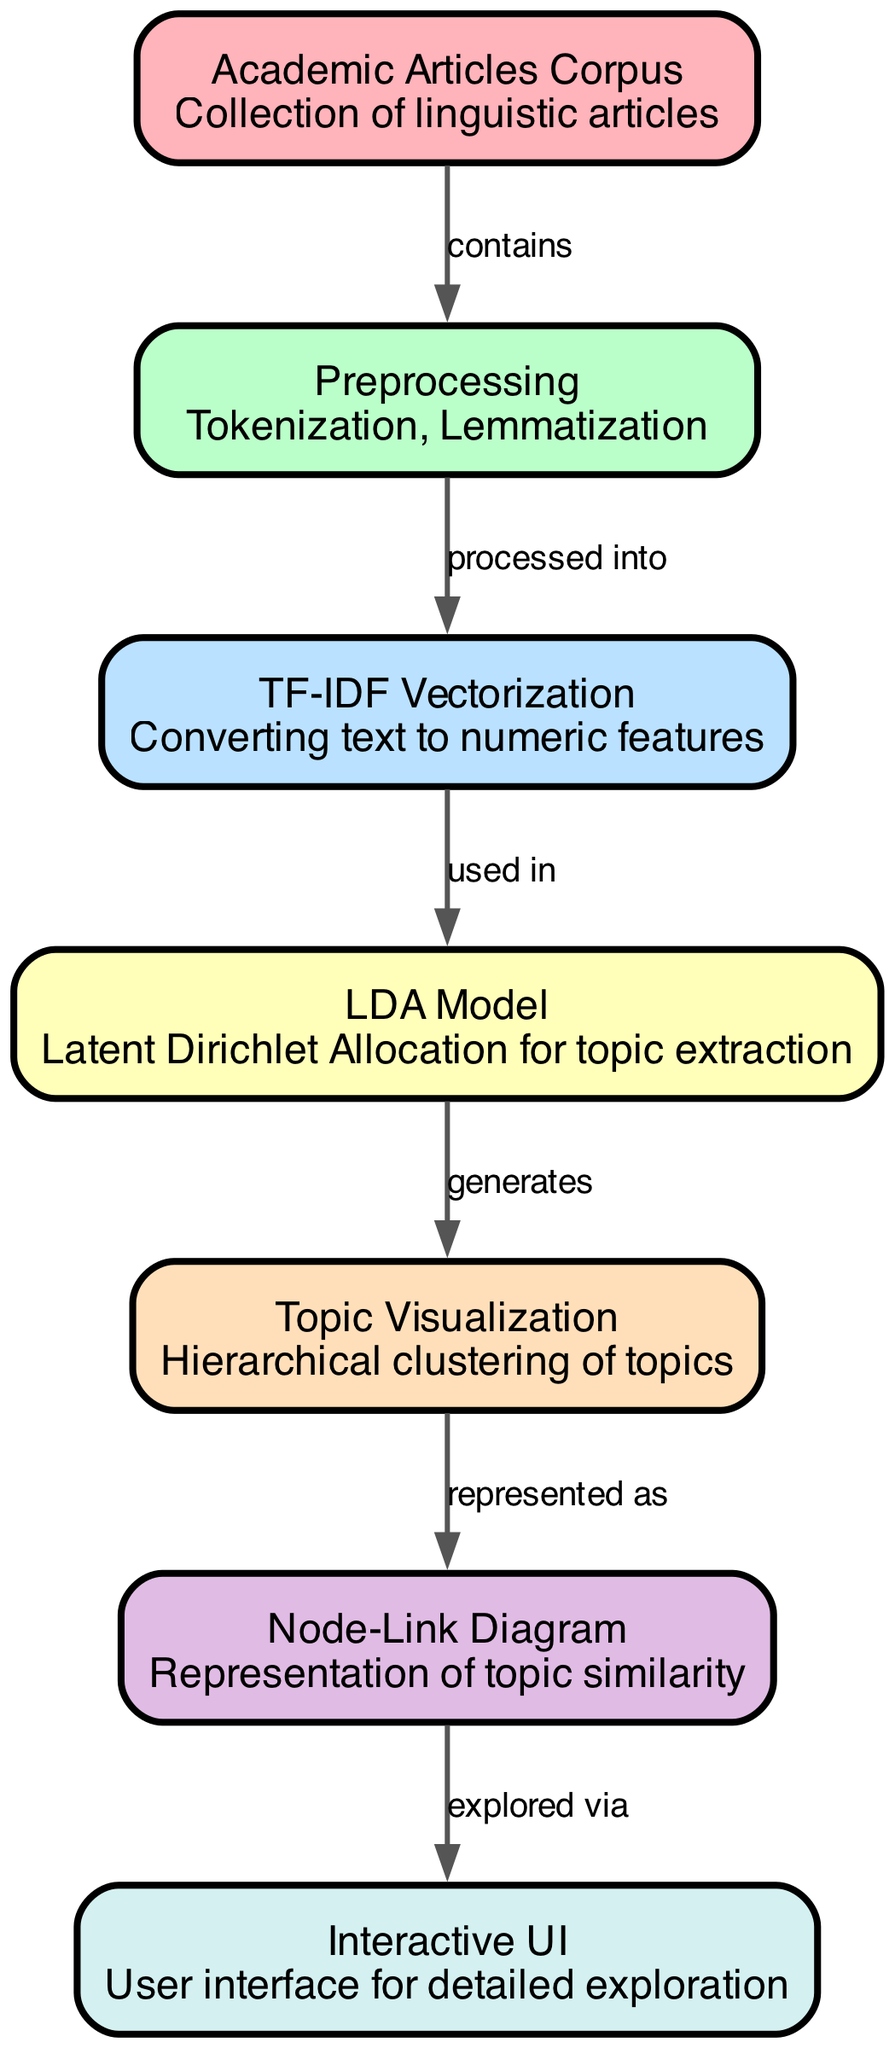What is the label of the first node? The first node in the diagram has the label "Academic Articles Corpus." It is the topmost node from which all the processes begin.
Answer: Academic Articles Corpus How many nodes are there in total? By counting all the listed nodes in the provided data, there are seven distinct nodes. This includes nodes for the corpus, preprocessing, vectorization, modeling, visualization, diagram representation, and user interface.
Answer: 7 What is the relationship between the preprocessing and the TF-IDF Vectorization nodes? The diagram indicates that preprocessing, which includes tokenization and lemmatization, is processed into TF-IDF Vectorization. This relationship is represented by the edge labeled "processed into."
Answer: processed into Which node generates the topic visualization? The "LDA Model" node is responsible for generating the "Topic Visualization." This connection is established through the edge labeled "generates."
Answer: LDA Model What describes the Node-Link Diagram in the context of this workflow? The Node-Link Diagram is a representation of topic similarity. It serves as a visual summary of how topics relate to one another based on the earlier processed data.
Answer: Representation of topic similarity Which node is explored via the Node-Link Diagram? The node that is explored via the Node-Link Diagram is the "Interactive UI." This is indicated by the edge labeled "explored via," showing that the Node-Link Diagram leads to user interaction.
Answer: Interactive UI What type of preprocessing is indicated in the diagram? The type of preprocessing mentioned in the diagram includes tokenization and lemmatization, which occur before vectorization. This is specifically outlined in the node description.
Answer: Tokenization, Lemmatization How do the "Topic Visualization" and "Node-Link Diagram" nodes connect? The connection between the "Topic Visualization" node and the "Node-Link Diagram" node shows that topic visualization is represented as a node-link diagram, highlighting their direct relationship through the edge labeled "represented as."
Answer: Represented as What is the function of the LDA Model in this diagram? The LDA Model functions to perform topic extraction from the articles in the corpus. It is a crucial step in the transformation process that leads to visualization.
Answer: Topic extraction 